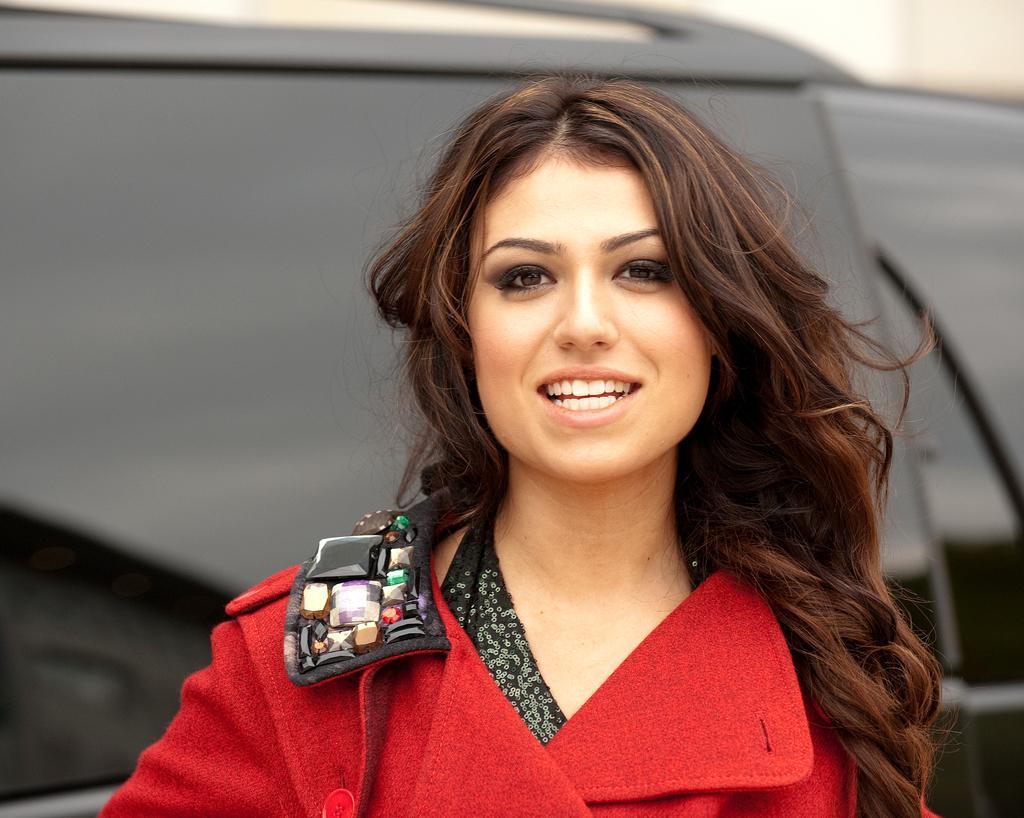In one or two sentences, can you explain what this image depicts? In this image we can see a woman smiling and posing for a photo and in the background, we can see an object which looks like a vehicle. 